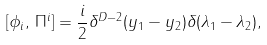<formula> <loc_0><loc_0><loc_500><loc_500>[ \phi _ { i } , \, \Pi ^ { i } ] = \frac { i } { 2 } \delta ^ { D - 2 } ( y _ { 1 } - y _ { 2 } ) \delta ( \lambda _ { 1 } - \lambda _ { 2 } ) ,</formula> 